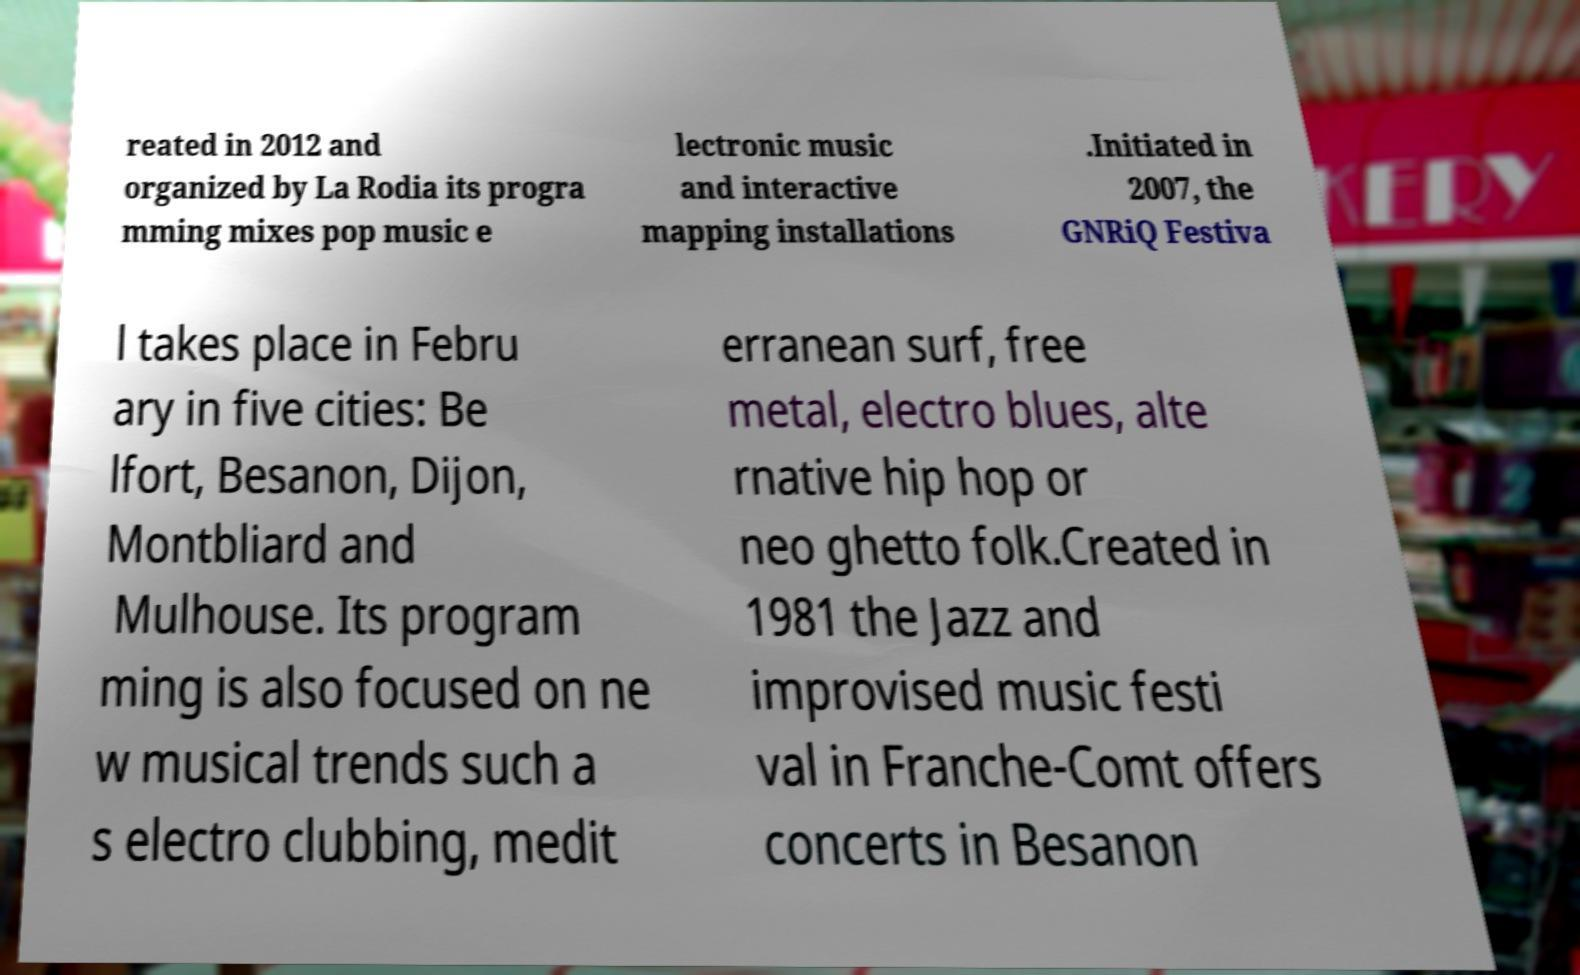Could you extract and type out the text from this image? reated in 2012 and organized by La Rodia its progra mming mixes pop music e lectronic music and interactive mapping installations .Initiated in 2007, the GNRiQ Festiva l takes place in Febru ary in five cities: Be lfort, Besanon, Dijon, Montbliard and Mulhouse. Its program ming is also focused on ne w musical trends such a s electro clubbing, medit erranean surf, free metal, electro blues, alte rnative hip hop or neo ghetto folk.Created in 1981 the Jazz and improvised music festi val in Franche-Comt offers concerts in Besanon 